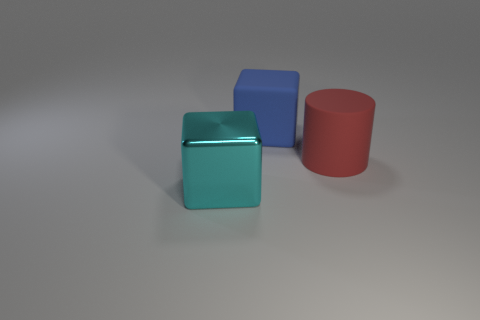Add 2 blue things. How many objects exist? 5 Subtract all cylinders. How many objects are left? 2 Add 1 big cyan things. How many big cyan things are left? 2 Add 1 yellow objects. How many yellow objects exist? 1 Subtract 0 blue cylinders. How many objects are left? 3 Subtract all big cyan metal objects. Subtract all blue shiny cubes. How many objects are left? 2 